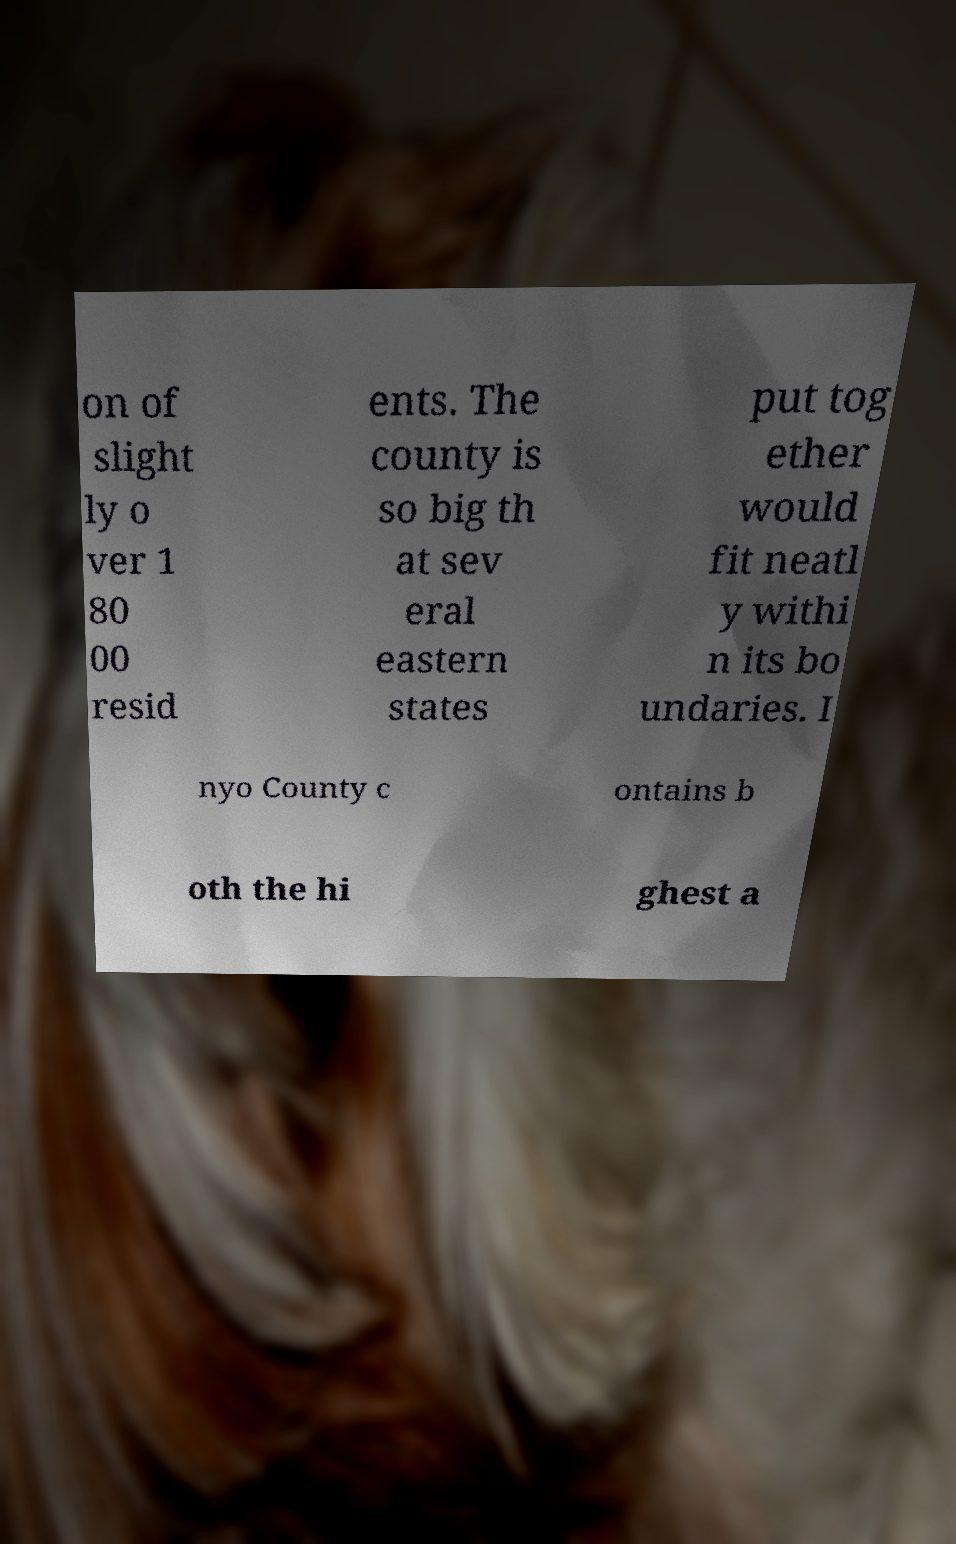Please read and relay the text visible in this image. What does it say? on of slight ly o ver 1 80 00 resid ents. The county is so big th at sev eral eastern states put tog ether would fit neatl y withi n its bo undaries. I nyo County c ontains b oth the hi ghest a 